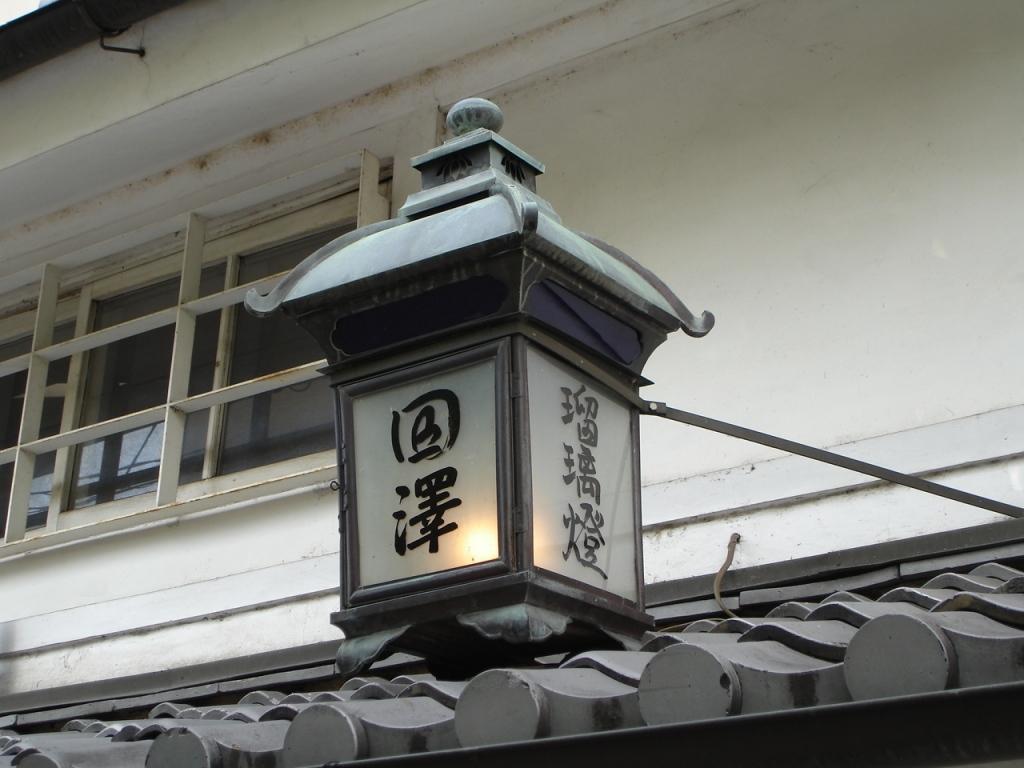In one or two sentences, can you explain what this image depicts? In the image there is a lamp on a roof and behind the lamp there is a window, beside the window there is a wall. 